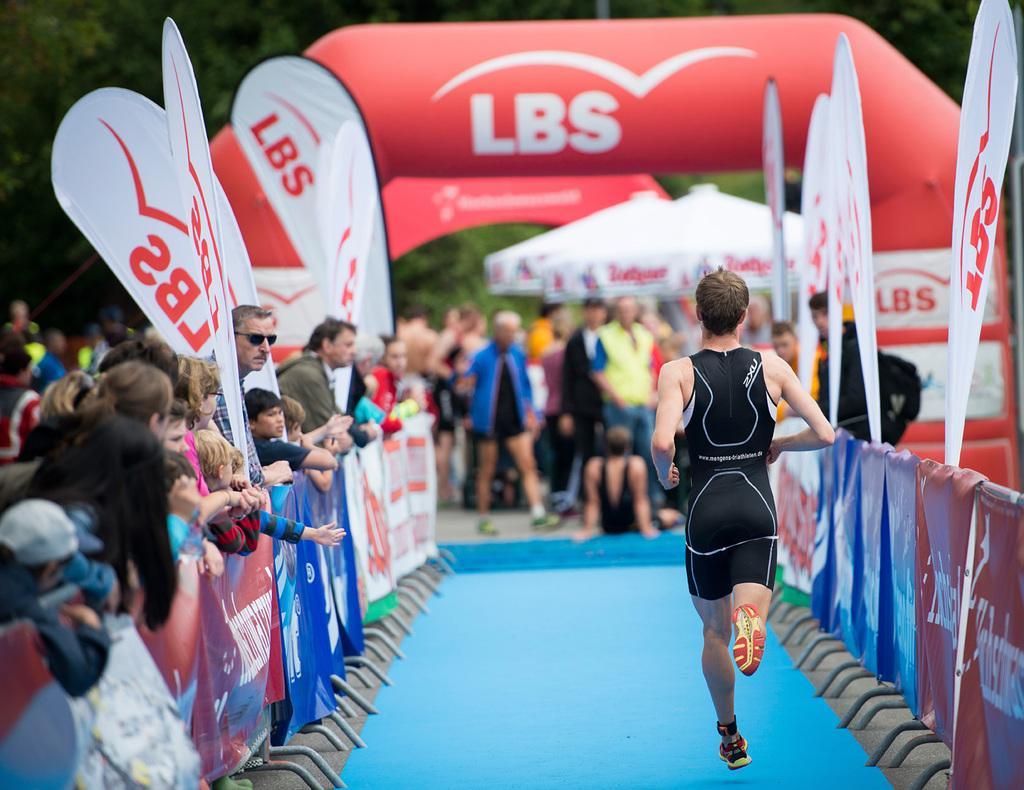How would you summarize this image in a sentence or two? In this image I see number of people and I see number of banners on which something is written and I see that it is blurred in the background and I see the blue color path over here and I see the trees. 